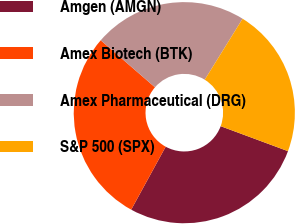<chart> <loc_0><loc_0><loc_500><loc_500><pie_chart><fcel>Amgen (AMGN)<fcel>Amex Biotech (BTK)<fcel>Amex Pharmaceutical (DRG)<fcel>S&P 500 (SPX)<nl><fcel>27.32%<fcel>28.39%<fcel>22.48%<fcel>21.82%<nl></chart> 